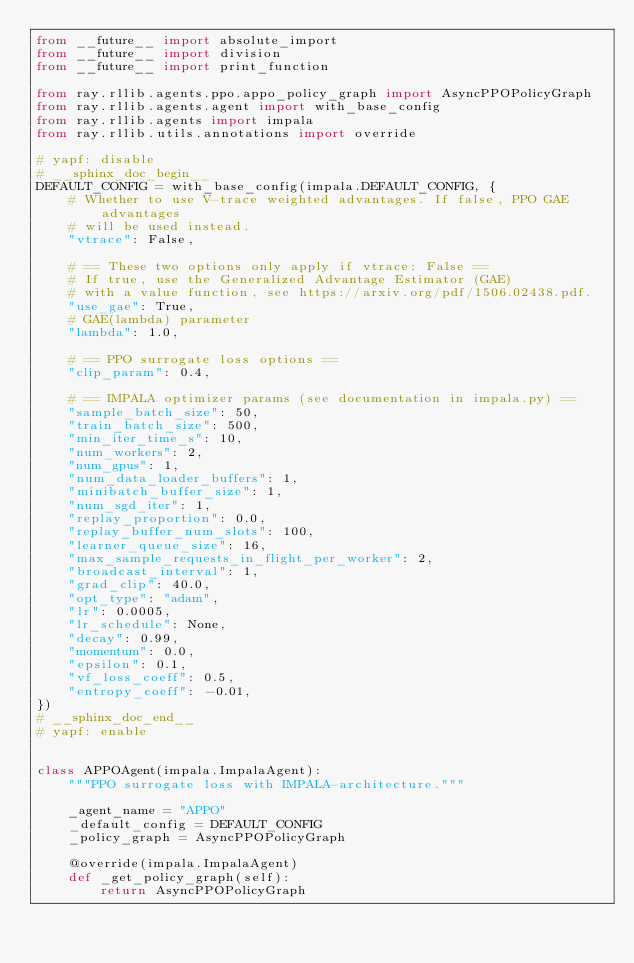Convert code to text. <code><loc_0><loc_0><loc_500><loc_500><_Python_>from __future__ import absolute_import
from __future__ import division
from __future__ import print_function

from ray.rllib.agents.ppo.appo_policy_graph import AsyncPPOPolicyGraph
from ray.rllib.agents.agent import with_base_config
from ray.rllib.agents import impala
from ray.rllib.utils.annotations import override

# yapf: disable
# __sphinx_doc_begin__
DEFAULT_CONFIG = with_base_config(impala.DEFAULT_CONFIG, {
    # Whether to use V-trace weighted advantages. If false, PPO GAE advantages
    # will be used instead.
    "vtrace": False,

    # == These two options only apply if vtrace: False ==
    # If true, use the Generalized Advantage Estimator (GAE)
    # with a value function, see https://arxiv.org/pdf/1506.02438.pdf.
    "use_gae": True,
    # GAE(lambda) parameter
    "lambda": 1.0,

    # == PPO surrogate loss options ==
    "clip_param": 0.4,

    # == IMPALA optimizer params (see documentation in impala.py) ==
    "sample_batch_size": 50,
    "train_batch_size": 500,
    "min_iter_time_s": 10,
    "num_workers": 2,
    "num_gpus": 1,
    "num_data_loader_buffers": 1,
    "minibatch_buffer_size": 1,
    "num_sgd_iter": 1,
    "replay_proportion": 0.0,
    "replay_buffer_num_slots": 100,
    "learner_queue_size": 16,
    "max_sample_requests_in_flight_per_worker": 2,
    "broadcast_interval": 1,
    "grad_clip": 40.0,
    "opt_type": "adam",
    "lr": 0.0005,
    "lr_schedule": None,
    "decay": 0.99,
    "momentum": 0.0,
    "epsilon": 0.1,
    "vf_loss_coeff": 0.5,
    "entropy_coeff": -0.01,
})
# __sphinx_doc_end__
# yapf: enable


class APPOAgent(impala.ImpalaAgent):
    """PPO surrogate loss with IMPALA-architecture."""

    _agent_name = "APPO"
    _default_config = DEFAULT_CONFIG
    _policy_graph = AsyncPPOPolicyGraph

    @override(impala.ImpalaAgent)
    def _get_policy_graph(self):
        return AsyncPPOPolicyGraph
</code> 